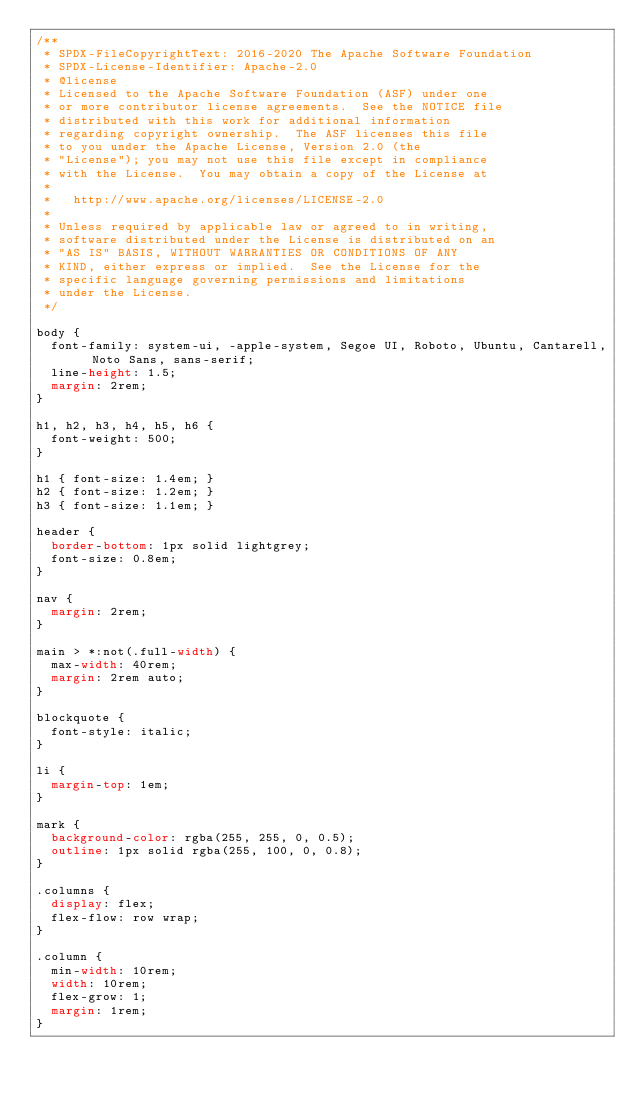Convert code to text. <code><loc_0><loc_0><loc_500><loc_500><_CSS_>/**
 * SPDX-FileCopyrightText: 2016-2020 The Apache Software Foundation
 * SPDX-License-Identifier: Apache-2.0
 * @license
 * Licensed to the Apache Software Foundation (ASF) under one
 * or more contributor license agreements.  See the NOTICE file
 * distributed with this work for additional information
 * regarding copyright ownership.  The ASF licenses this file
 * to you under the Apache License, Version 2.0 (the
 * "License"); you may not use this file except in compliance
 * with the License.  You may obtain a copy of the License at
 *
 *   http://www.apache.org/licenses/LICENSE-2.0
 *
 * Unless required by applicable law or agreed to in writing,
 * software distributed under the License is distributed on an
 * "AS IS" BASIS, WITHOUT WARRANTIES OR CONDITIONS OF ANY
 * KIND, either express or implied.  See the License for the
 * specific language governing permissions and limitations
 * under the License.
 */

body {
  font-family: system-ui, -apple-system, Segoe UI, Roboto, Ubuntu, Cantarell, Noto Sans, sans-serif;
  line-height: 1.5;
  margin: 2rem;
}

h1, h2, h3, h4, h5, h6 {
  font-weight: 500;
}

h1 { font-size: 1.4em; }
h2 { font-size: 1.2em; }
h3 { font-size: 1.1em; }

header {
  border-bottom: 1px solid lightgrey;
  font-size: 0.8em;
}

nav {
  margin: 2rem;
}

main > *:not(.full-width) {
  max-width: 40rem;
  margin: 2rem auto;
}

blockquote {
  font-style: italic;
}

li {
  margin-top: 1em;
}

mark {
  background-color: rgba(255, 255, 0, 0.5);
  outline: 1px solid rgba(255, 100, 0, 0.8);
}

.columns {
  display: flex;
  flex-flow: row wrap;
}

.column {
  min-width: 10rem;
  width: 10rem;
  flex-grow: 1;
  margin: 1rem;
}
</code> 